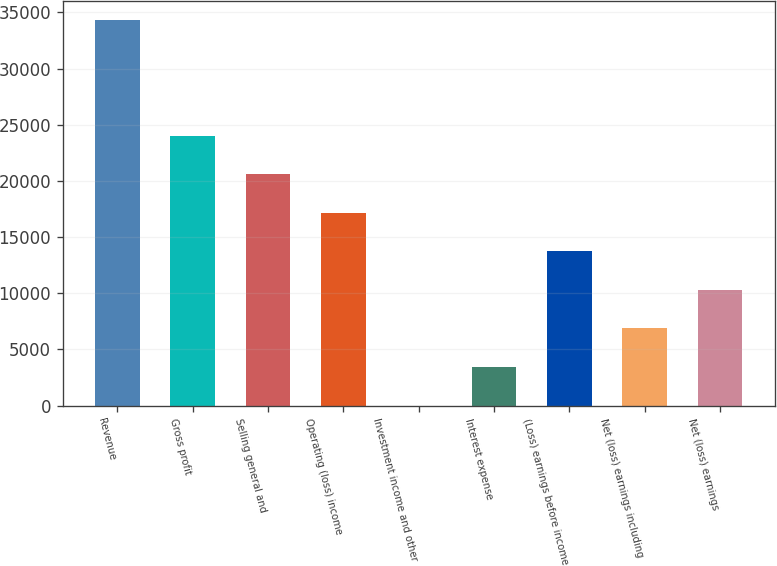Convert chart. <chart><loc_0><loc_0><loc_500><loc_500><bar_chart><fcel>Revenue<fcel>Gross profit<fcel>Selling general and<fcel>Operating (loss) income<fcel>Investment income and other<fcel>Interest expense<fcel>(Loss) earnings before income<fcel>Net (loss) earnings including<fcel>Net (loss) earnings<nl><fcel>34347<fcel>24043.2<fcel>20608.6<fcel>17174<fcel>1<fcel>3435.6<fcel>13739.4<fcel>6870.2<fcel>10304.8<nl></chart> 